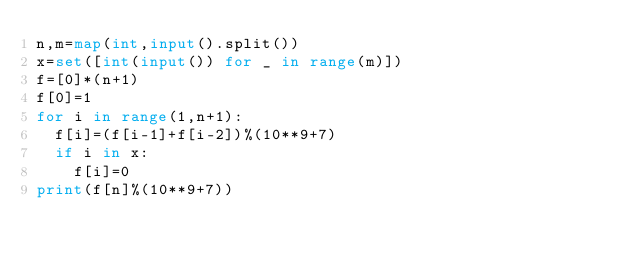<code> <loc_0><loc_0><loc_500><loc_500><_Python_>n,m=map(int,input().split())
x=set([int(input()) for _ in range(m)])
f=[0]*(n+1)
f[0]=1
for i in range(1,n+1):
  f[i]=(f[i-1]+f[i-2])%(10**9+7)
  if i in x:
    f[i]=0
print(f[n]%(10**9+7))</code> 